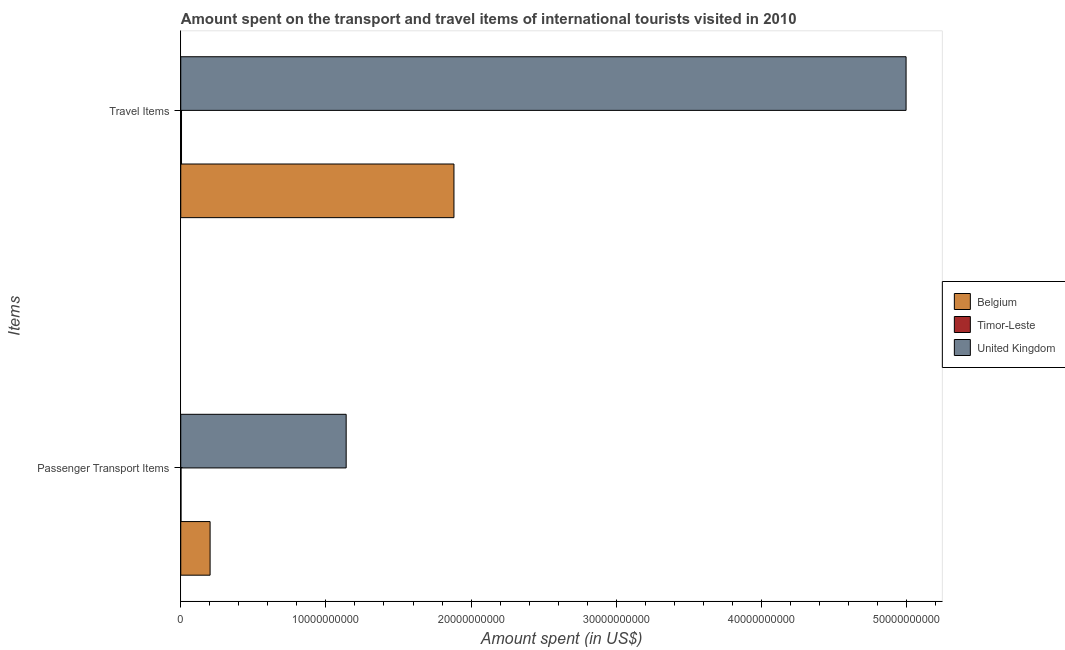How many different coloured bars are there?
Offer a terse response. 3. How many groups of bars are there?
Your response must be concise. 2. Are the number of bars per tick equal to the number of legend labels?
Your answer should be very brief. Yes. Are the number of bars on each tick of the Y-axis equal?
Offer a very short reply. Yes. How many bars are there on the 1st tick from the top?
Your response must be concise. 3. What is the label of the 2nd group of bars from the top?
Offer a very short reply. Passenger Transport Items. What is the amount spent in travel items in United Kingdom?
Offer a terse response. 5.00e+1. Across all countries, what is the maximum amount spent in travel items?
Make the answer very short. 5.00e+1. Across all countries, what is the minimum amount spent in travel items?
Your answer should be very brief. 5.20e+07. In which country was the amount spent on passenger transport items minimum?
Your answer should be very brief. Timor-Leste. What is the total amount spent in travel items in the graph?
Ensure brevity in your answer.  6.88e+1. What is the difference between the amount spent in travel items in Timor-Leste and that in United Kingdom?
Make the answer very short. -4.99e+1. What is the difference between the amount spent on passenger transport items in Belgium and the amount spent in travel items in Timor-Leste?
Provide a short and direct response. 1.97e+09. What is the average amount spent in travel items per country?
Your response must be concise. 2.29e+1. What is the difference between the amount spent in travel items and amount spent on passenger transport items in Belgium?
Your answer should be compact. 1.68e+1. What is the ratio of the amount spent in travel items in Timor-Leste to that in Belgium?
Give a very brief answer. 0. Is the amount spent in travel items in United Kingdom less than that in Timor-Leste?
Offer a terse response. No. What does the 2nd bar from the top in Passenger Transport Items represents?
Give a very brief answer. Timor-Leste. What does the 2nd bar from the bottom in Travel Items represents?
Ensure brevity in your answer.  Timor-Leste. How many countries are there in the graph?
Offer a very short reply. 3. What is the difference between two consecutive major ticks on the X-axis?
Give a very brief answer. 1.00e+1. Are the values on the major ticks of X-axis written in scientific E-notation?
Keep it short and to the point. No. Does the graph contain any zero values?
Provide a succinct answer. No. Where does the legend appear in the graph?
Keep it short and to the point. Center right. What is the title of the graph?
Offer a terse response. Amount spent on the transport and travel items of international tourists visited in 2010. Does "Cuba" appear as one of the legend labels in the graph?
Your answer should be compact. No. What is the label or title of the X-axis?
Ensure brevity in your answer.  Amount spent (in US$). What is the label or title of the Y-axis?
Your answer should be very brief. Items. What is the Amount spent (in US$) in Belgium in Passenger Transport Items?
Your answer should be compact. 2.02e+09. What is the Amount spent (in US$) in Timor-Leste in Passenger Transport Items?
Offer a terse response. 1.60e+07. What is the Amount spent (in US$) in United Kingdom in Passenger Transport Items?
Give a very brief answer. 1.14e+1. What is the Amount spent (in US$) in Belgium in Travel Items?
Make the answer very short. 1.88e+1. What is the Amount spent (in US$) of Timor-Leste in Travel Items?
Your answer should be compact. 5.20e+07. What is the Amount spent (in US$) in United Kingdom in Travel Items?
Your response must be concise. 5.00e+1. Across all Items, what is the maximum Amount spent (in US$) in Belgium?
Your response must be concise. 1.88e+1. Across all Items, what is the maximum Amount spent (in US$) of Timor-Leste?
Your response must be concise. 5.20e+07. Across all Items, what is the maximum Amount spent (in US$) in United Kingdom?
Your answer should be compact. 5.00e+1. Across all Items, what is the minimum Amount spent (in US$) in Belgium?
Provide a short and direct response. 2.02e+09. Across all Items, what is the minimum Amount spent (in US$) of Timor-Leste?
Your answer should be compact. 1.60e+07. Across all Items, what is the minimum Amount spent (in US$) in United Kingdom?
Offer a very short reply. 1.14e+1. What is the total Amount spent (in US$) of Belgium in the graph?
Make the answer very short. 2.08e+1. What is the total Amount spent (in US$) in Timor-Leste in the graph?
Your response must be concise. 6.80e+07. What is the total Amount spent (in US$) in United Kingdom in the graph?
Provide a short and direct response. 6.14e+1. What is the difference between the Amount spent (in US$) of Belgium in Passenger Transport Items and that in Travel Items?
Your answer should be very brief. -1.68e+1. What is the difference between the Amount spent (in US$) of Timor-Leste in Passenger Transport Items and that in Travel Items?
Provide a short and direct response. -3.60e+07. What is the difference between the Amount spent (in US$) in United Kingdom in Passenger Transport Items and that in Travel Items?
Keep it short and to the point. -3.86e+1. What is the difference between the Amount spent (in US$) of Belgium in Passenger Transport Items and the Amount spent (in US$) of Timor-Leste in Travel Items?
Offer a very short reply. 1.97e+09. What is the difference between the Amount spent (in US$) in Belgium in Passenger Transport Items and the Amount spent (in US$) in United Kingdom in Travel Items?
Your answer should be very brief. -4.80e+1. What is the difference between the Amount spent (in US$) of Timor-Leste in Passenger Transport Items and the Amount spent (in US$) of United Kingdom in Travel Items?
Your response must be concise. -5.00e+1. What is the average Amount spent (in US$) in Belgium per Items?
Keep it short and to the point. 1.04e+1. What is the average Amount spent (in US$) in Timor-Leste per Items?
Offer a very short reply. 3.40e+07. What is the average Amount spent (in US$) in United Kingdom per Items?
Keep it short and to the point. 3.07e+1. What is the difference between the Amount spent (in US$) in Belgium and Amount spent (in US$) in Timor-Leste in Passenger Transport Items?
Give a very brief answer. 2.00e+09. What is the difference between the Amount spent (in US$) in Belgium and Amount spent (in US$) in United Kingdom in Passenger Transport Items?
Provide a succinct answer. -9.38e+09. What is the difference between the Amount spent (in US$) of Timor-Leste and Amount spent (in US$) of United Kingdom in Passenger Transport Items?
Give a very brief answer. -1.14e+1. What is the difference between the Amount spent (in US$) of Belgium and Amount spent (in US$) of Timor-Leste in Travel Items?
Keep it short and to the point. 1.88e+1. What is the difference between the Amount spent (in US$) of Belgium and Amount spent (in US$) of United Kingdom in Travel Items?
Make the answer very short. -3.12e+1. What is the difference between the Amount spent (in US$) in Timor-Leste and Amount spent (in US$) in United Kingdom in Travel Items?
Your response must be concise. -4.99e+1. What is the ratio of the Amount spent (in US$) in Belgium in Passenger Transport Items to that in Travel Items?
Make the answer very short. 0.11. What is the ratio of the Amount spent (in US$) in Timor-Leste in Passenger Transport Items to that in Travel Items?
Offer a very short reply. 0.31. What is the ratio of the Amount spent (in US$) in United Kingdom in Passenger Transport Items to that in Travel Items?
Your response must be concise. 0.23. What is the difference between the highest and the second highest Amount spent (in US$) of Belgium?
Ensure brevity in your answer.  1.68e+1. What is the difference between the highest and the second highest Amount spent (in US$) of Timor-Leste?
Your response must be concise. 3.60e+07. What is the difference between the highest and the second highest Amount spent (in US$) in United Kingdom?
Your answer should be compact. 3.86e+1. What is the difference between the highest and the lowest Amount spent (in US$) of Belgium?
Offer a very short reply. 1.68e+1. What is the difference between the highest and the lowest Amount spent (in US$) in Timor-Leste?
Ensure brevity in your answer.  3.60e+07. What is the difference between the highest and the lowest Amount spent (in US$) in United Kingdom?
Provide a succinct answer. 3.86e+1. 